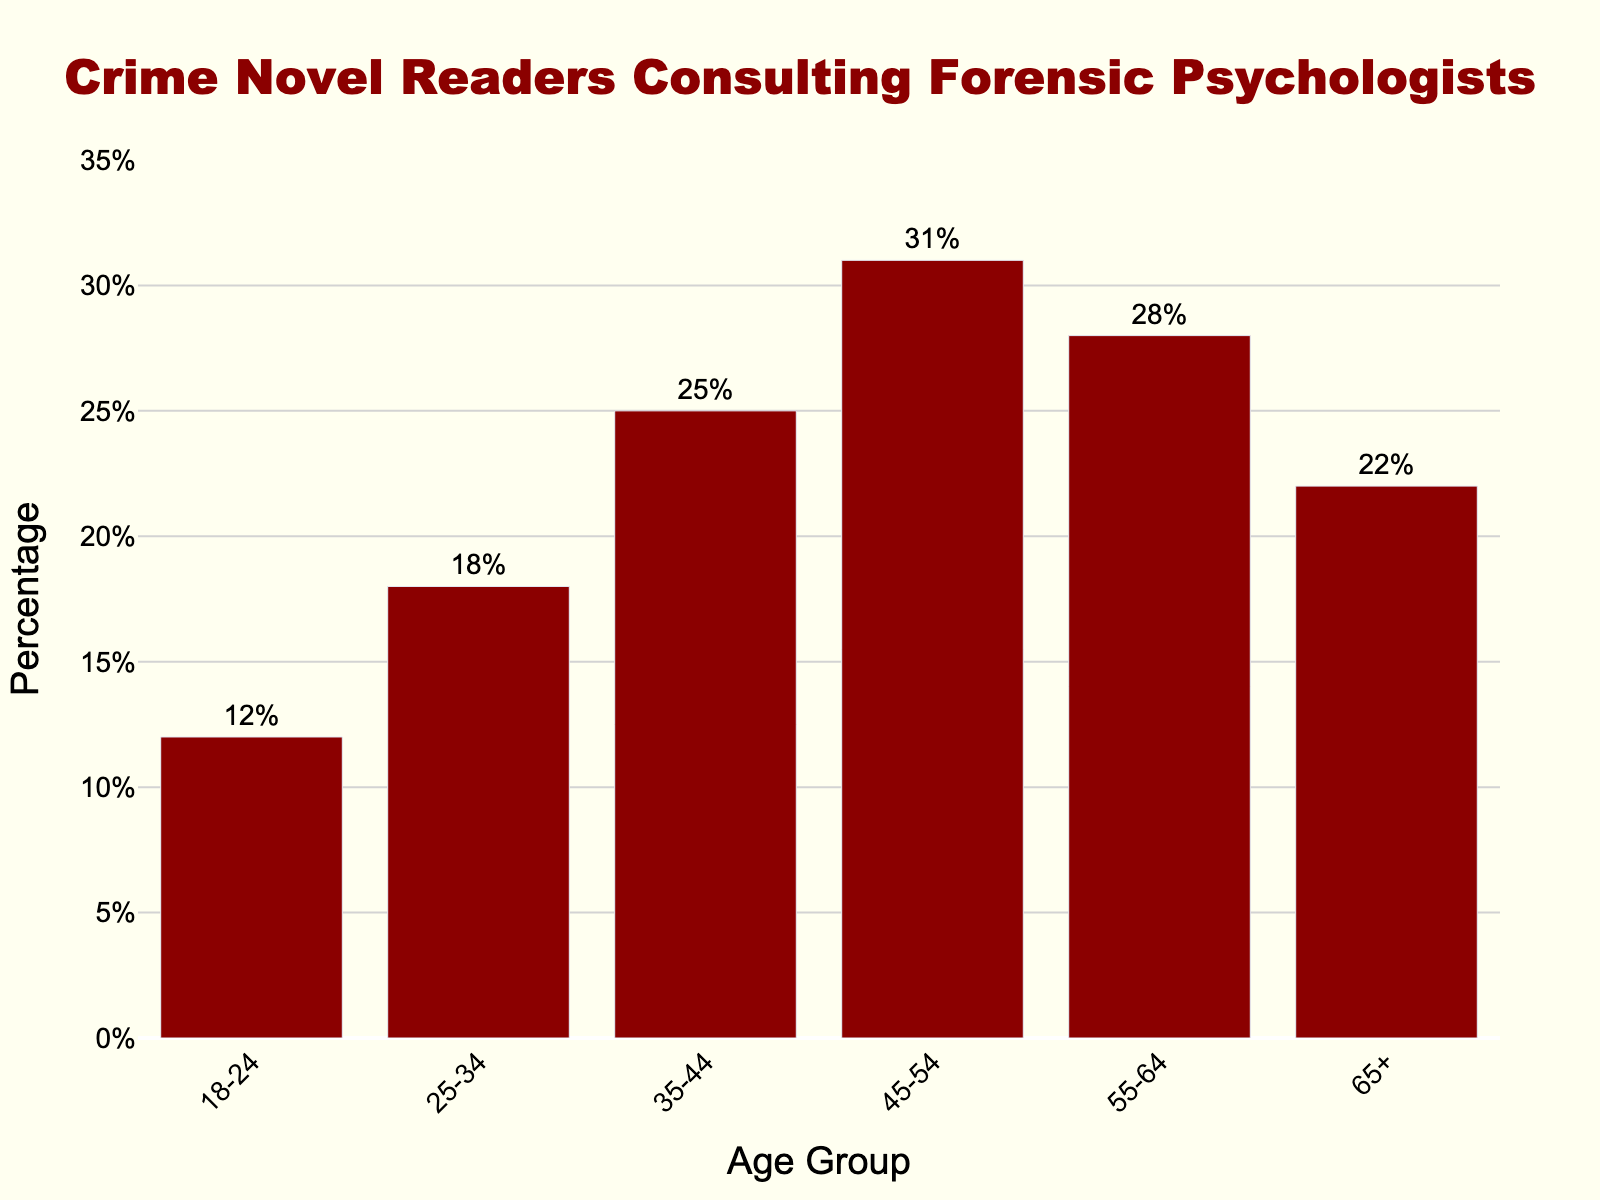Which age group has the highest percentage of crime novel readers consulting forensic psychologists for book recommendations? The figure shows that the 45-54 age group has the highest bar, with a percentage of 31%.
Answer: 45-54 Which age group has the lowest percentage of crime novel readers consulting forensic psychologists for book recommendations? The figure shows that the 18-24 age group has the smallest bar, with a percentage of 12%.
Answer: 18-24 What is the difference in percentage between the 25-34 and 65+ age groups? The figure shows percentages of 18% for 25-34 and 22% for 65+, so the difference is 22% - 18% = 4%.
Answer: 4% What is the average percentage of crime novel readers consulting forensic psychologists across all age groups? Adding the percentages: 12% + 18% + 25% + 31% + 28% + 22% = 136, then dividing by the number of age groups (6), the average is 136/6 ≈ 22.67%.
Answer: 22.67% Is the percentage of crime novel readers consulting forensic psychologists higher in the 55-64 age group compared to the 35-44 age group? The figure shows 28% for 55-64 and 25% for 35-44, making it higher in the 55-64 age group.
Answer: Yes What's the combined percentage of crime novel readers in the 35-44, 45-54, and 55-64 age groups? Adding the percentages: 25% (35-44) + 31% (45-54) + 28% (55-64), the combined percentage is 25% + 31% + 28% = 84%.
Answer: 84% How much greater is the percentage for the 45-54 age group compared to the 18-24 age group? The figure shows 31% for 45-54 and 12% for 18-24, so the difference is 31% - 12% = 19%.
Answer: 19% Among the 55-64 and 65+ age groups, which has a lower percentage and by how much? The figure shows 28% for 55-64 and 22% for 65+, so the 65+ group has a lower percentage by 28% - 22% = 6%.
Answer: 65+, 6% 